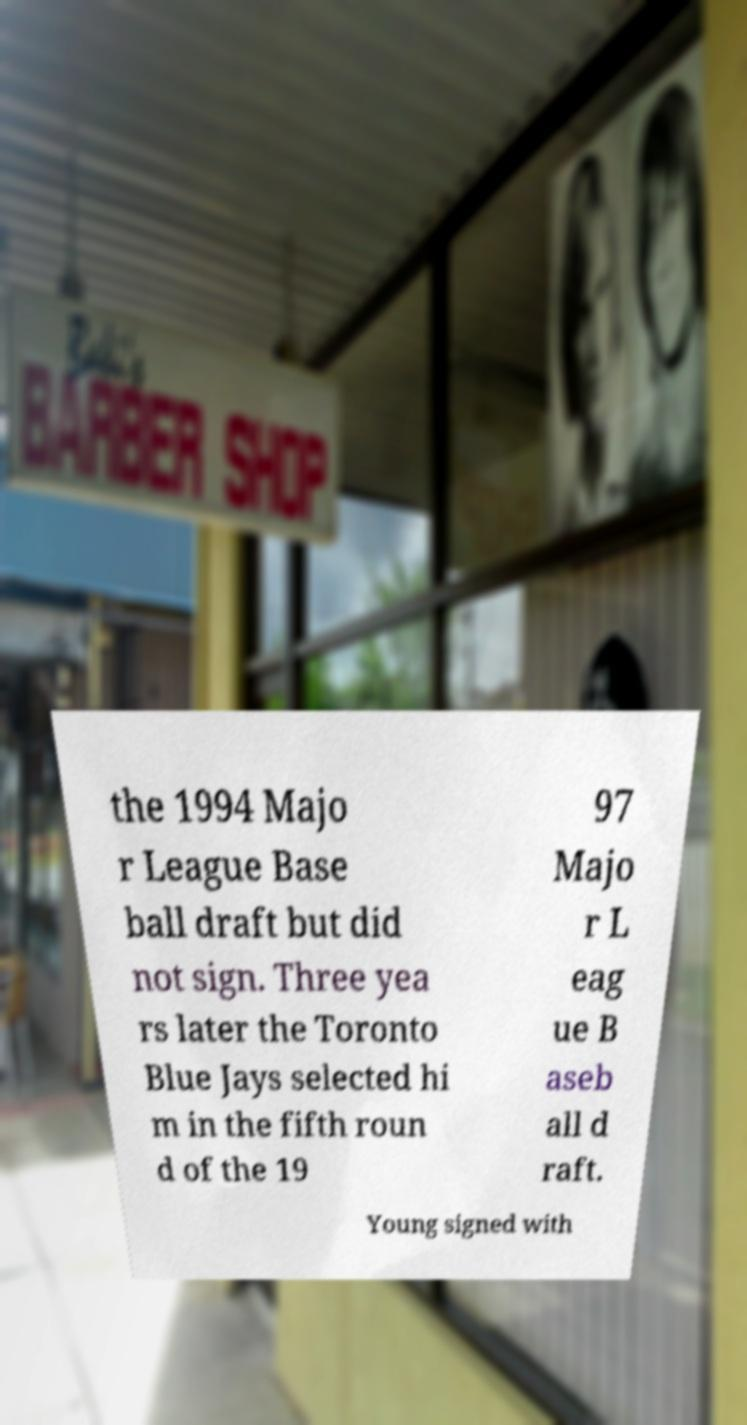Please read and relay the text visible in this image. What does it say? the 1994 Majo r League Base ball draft but did not sign. Three yea rs later the Toronto Blue Jays selected hi m in the fifth roun d of the 19 97 Majo r L eag ue B aseb all d raft. Young signed with 